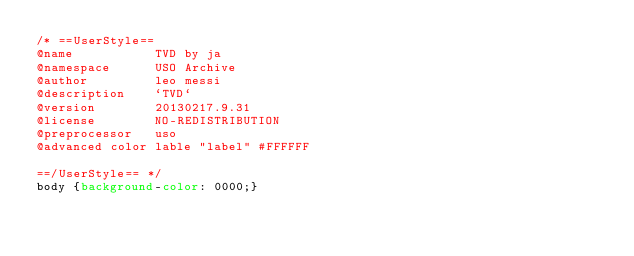<code> <loc_0><loc_0><loc_500><loc_500><_CSS_>/* ==UserStyle==
@name           TVD by ja
@namespace      USO Archive
@author         leo messi
@description    `TVD`
@version        20130217.9.31
@license        NO-REDISTRIBUTION
@preprocessor   uso
@advanced color lable "label" #FFFFFF

==/UserStyle== */
body {background-color: 0000;}</code> 